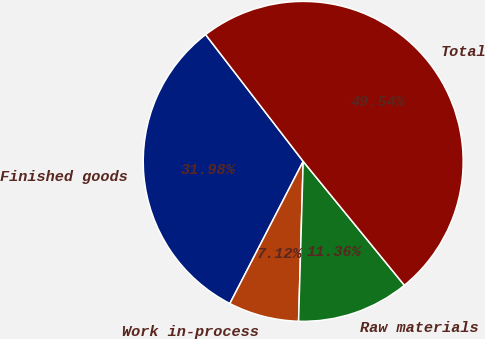Convert chart to OTSL. <chart><loc_0><loc_0><loc_500><loc_500><pie_chart><fcel>Finished goods<fcel>Work in-process<fcel>Raw materials<fcel>Total<nl><fcel>31.98%<fcel>7.12%<fcel>11.36%<fcel>49.54%<nl></chart> 